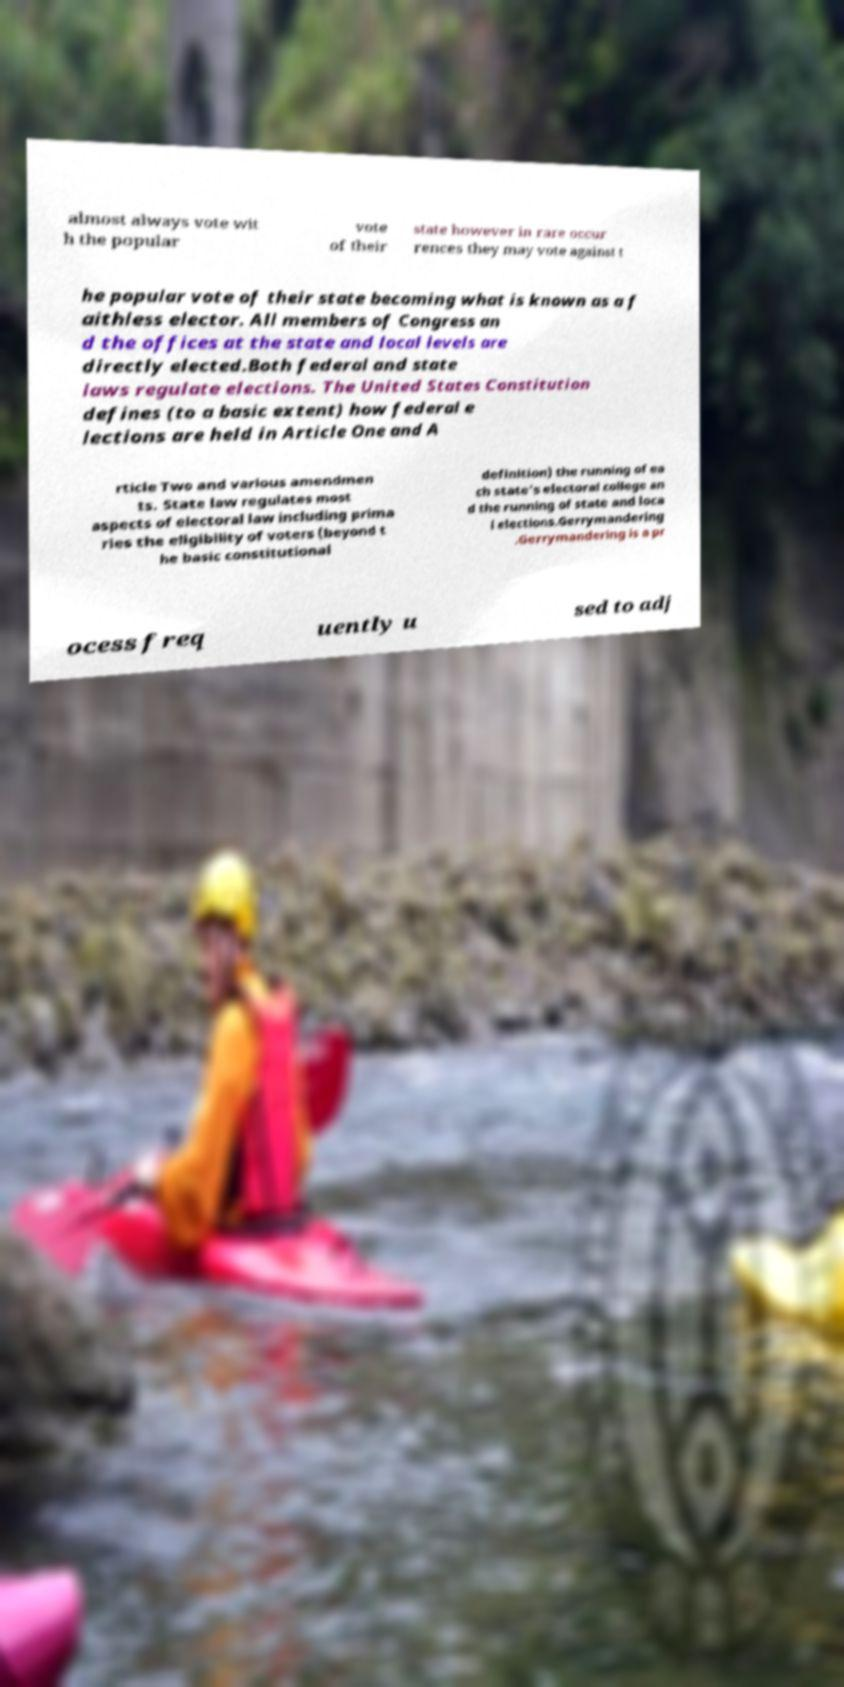There's text embedded in this image that I need extracted. Can you transcribe it verbatim? almost always vote wit h the popular vote of their state however in rare occur rences they may vote against t he popular vote of their state becoming what is known as a f aithless elector. All members of Congress an d the offices at the state and local levels are directly elected.Both federal and state laws regulate elections. The United States Constitution defines (to a basic extent) how federal e lections are held in Article One and A rticle Two and various amendmen ts. State law regulates most aspects of electoral law including prima ries the eligibility of voters (beyond t he basic constitutional definition) the running of ea ch state's electoral college an d the running of state and loca l elections.Gerrymandering .Gerrymandering is a pr ocess freq uently u sed to adj 